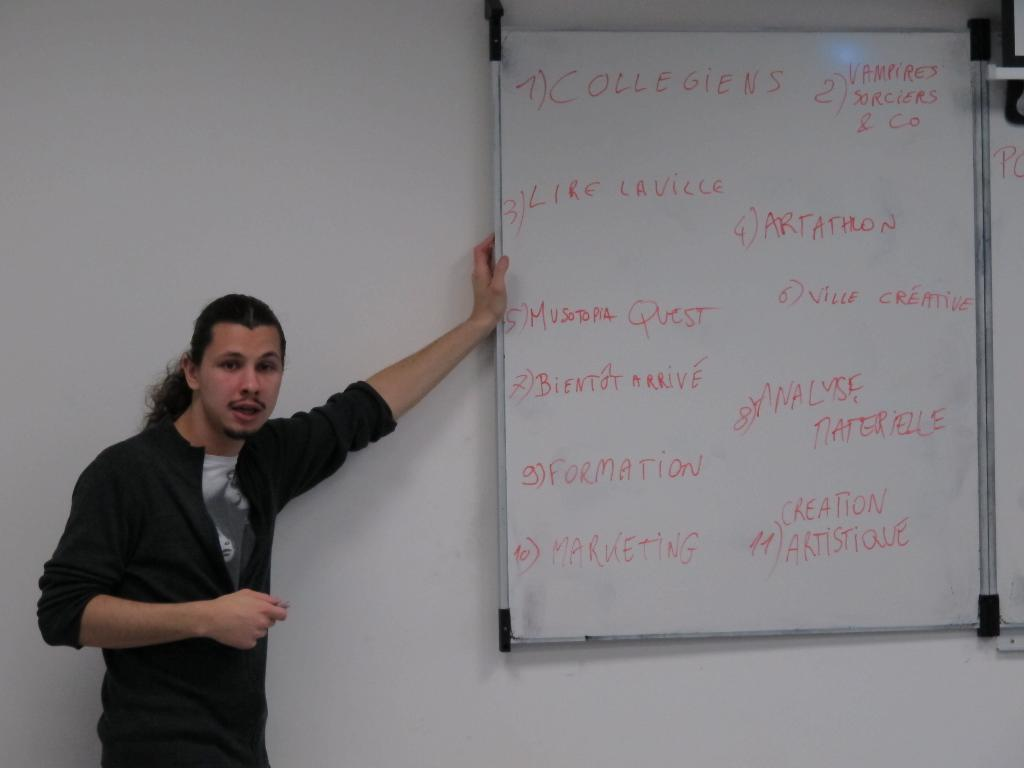<image>
Describe the image concisely. A man is standing beside a white board with the word creation written on it. 